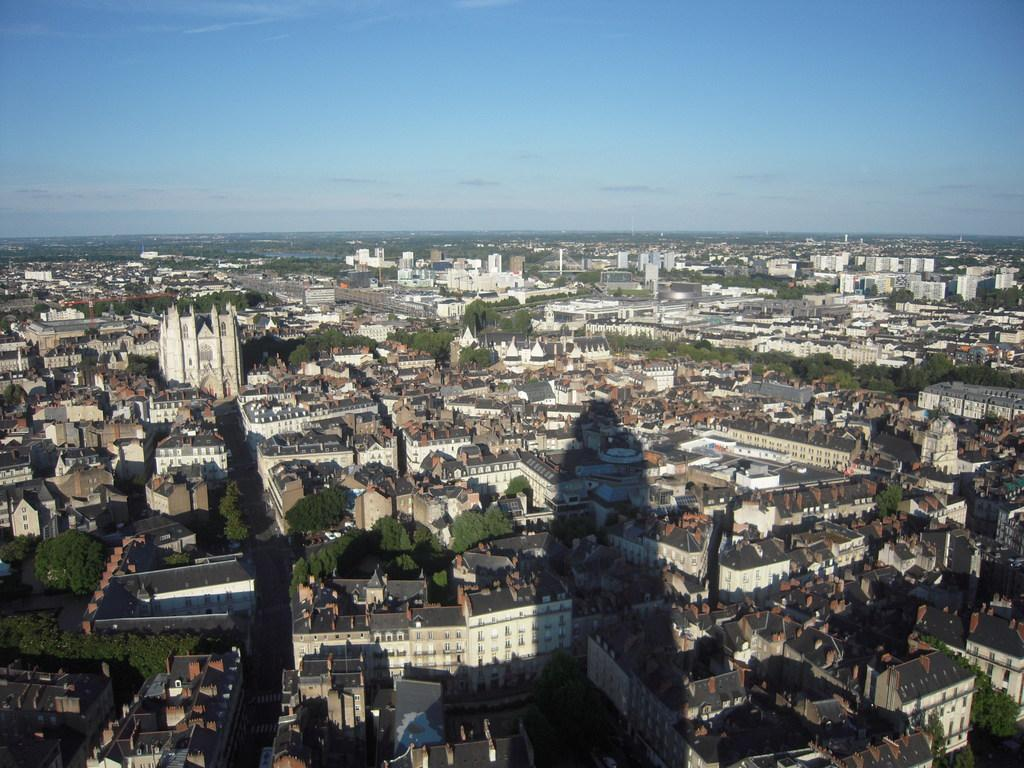What type of structures can be seen in the image? There are buildings in the image. What other natural elements are present in the image? There are trees in the image. Can you describe any objects visible in the image? Yes, there are objects visible in the image. What can be seen in the background of the image? The sky is visible in the background of the image. What type of thrill can be experienced by the stove in the image? There is no stove present in the image, so it cannot be determined if any thrill is experienced. 